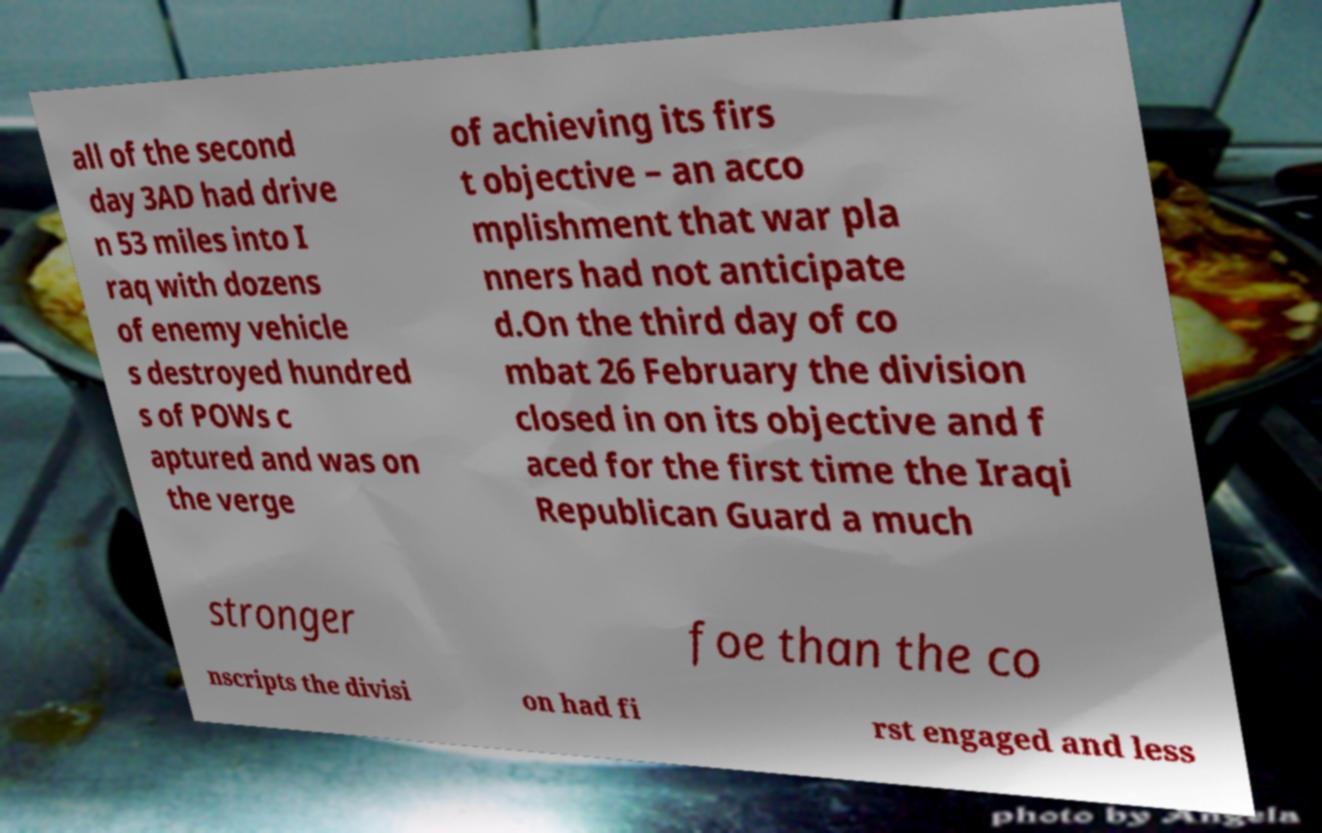Please read and relay the text visible in this image. What does it say? all of the second day 3AD had drive n 53 miles into I raq with dozens of enemy vehicle s destroyed hundred s of POWs c aptured and was on the verge of achieving its firs t objective – an acco mplishment that war pla nners had not anticipate d.On the third day of co mbat 26 February the division closed in on its objective and f aced for the first time the Iraqi Republican Guard a much stronger foe than the co nscripts the divisi on had fi rst engaged and less 